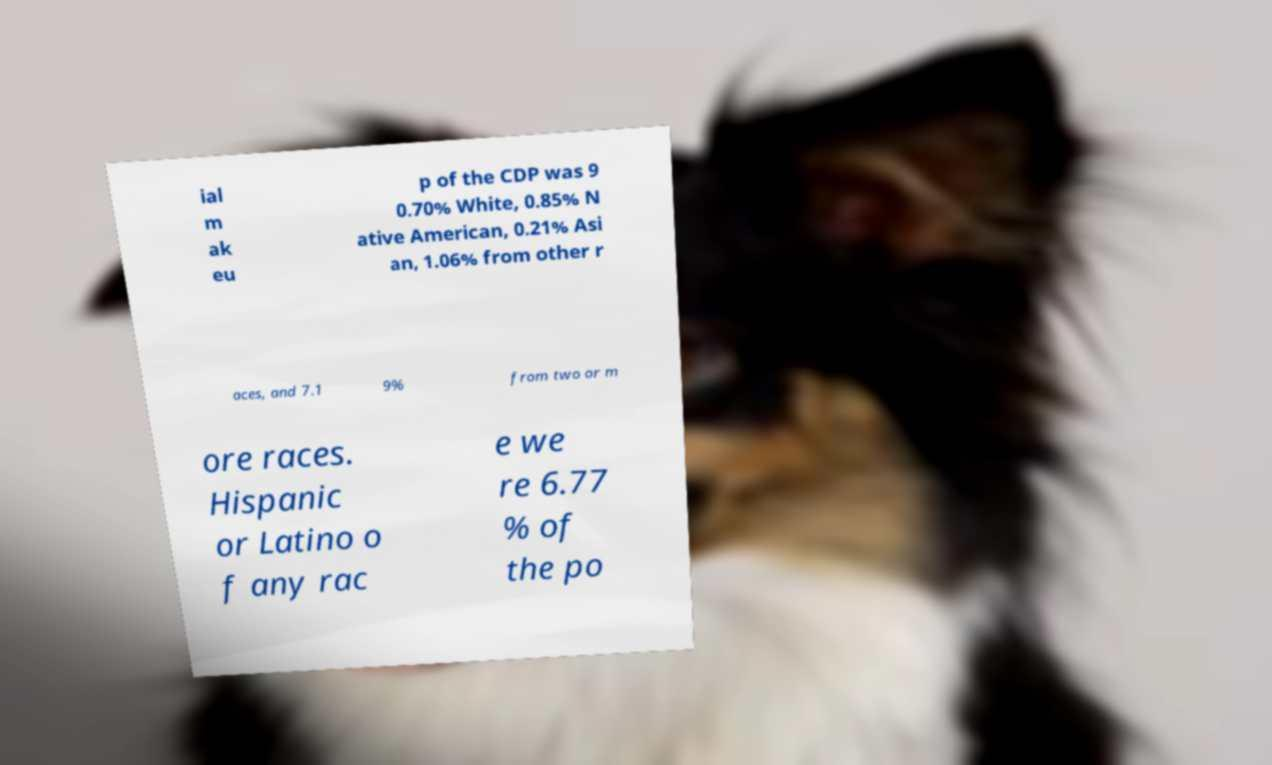I need the written content from this picture converted into text. Can you do that? ial m ak eu p of the CDP was 9 0.70% White, 0.85% N ative American, 0.21% Asi an, 1.06% from other r aces, and 7.1 9% from two or m ore races. Hispanic or Latino o f any rac e we re 6.77 % of the po 